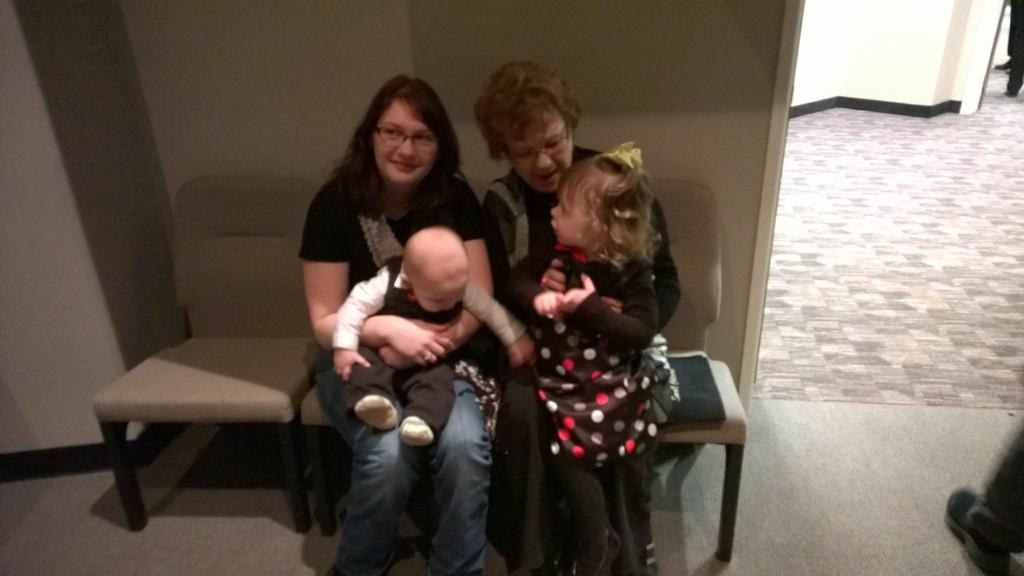How many people are in the image? There are two women in the image. What are the women doing in the image? The women are sitting on a chair. Can you describe the furniture in the image? There is a chair in the image. Reasoning: Let's think step by following the guidelines to produce the conversation. We start by identifying the main subjects in the image, which are the two women. Then, we describe their actions, which is sitting on a chair. Finally, we mention the presence of a chair in the image. We avoid yes/no questions and ensure that the language is simple and clear. Absurd Question/Answer: What type of trousers is the snake wearing in the image? There is no snake or trousers present in the image. Who is the friend of the women in the image? The provided facts do not mention any friends or relationships between the women in the image. What type of trousers is the snake wearing in the image? There is no snake or trousers present in the image. Who is the friend of the women in the image? The provided facts do not mention any friends or relationships between the women in the image. 